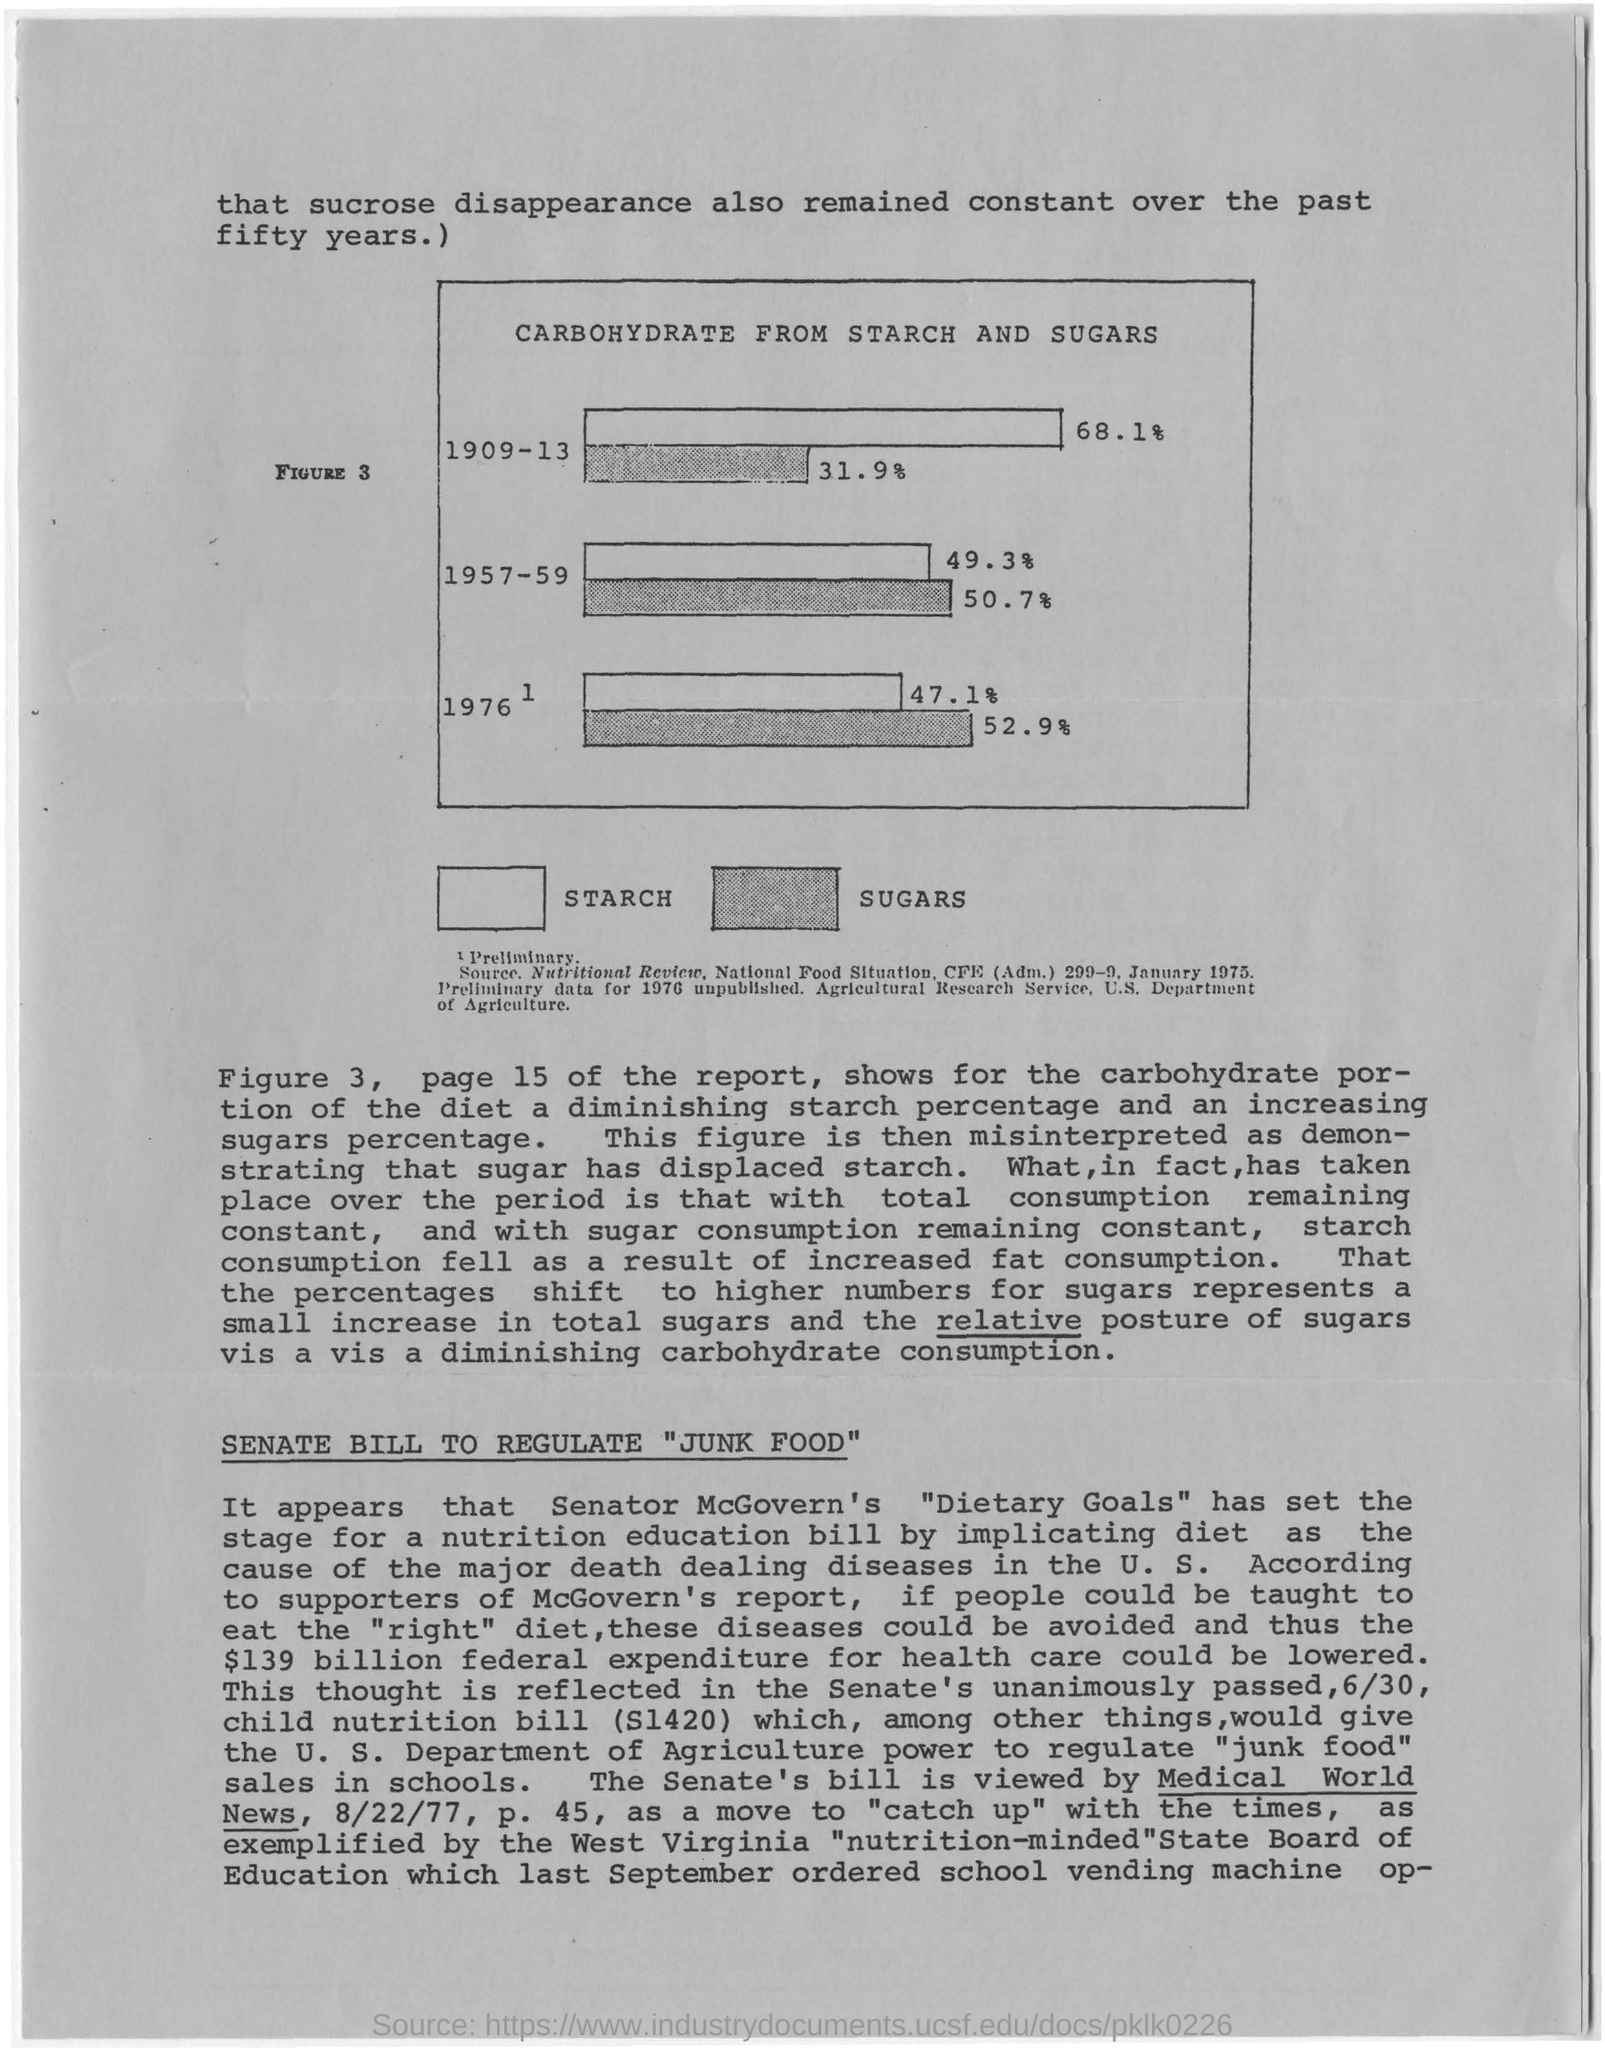Outline some significant characteristics in this image. Over the past fifty years, the rate of sucrose disappearance has remained constant, The report referred to is on page 15. The levels of carbohydrates derived from starch were particularly high during the years 1909-13. In 1976, the amount of carbohydrates derived from sugars was 52.9 grams. 